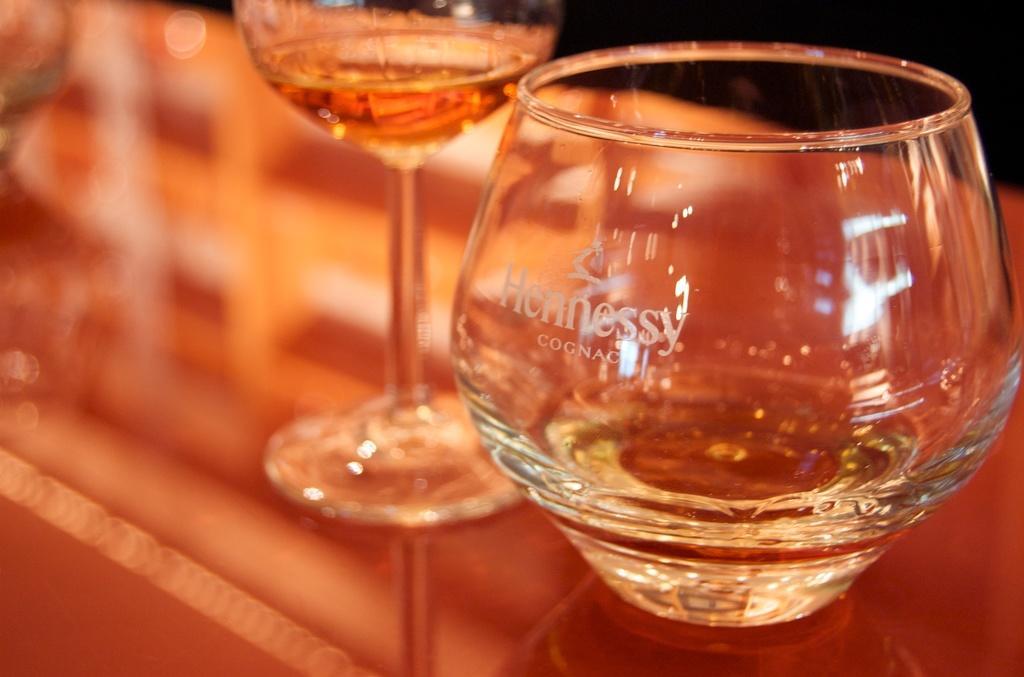Please provide a concise description of this image. In this picture we can see two glasses of drinks in the front, there is some text on this glass, we can see a blurry background. 